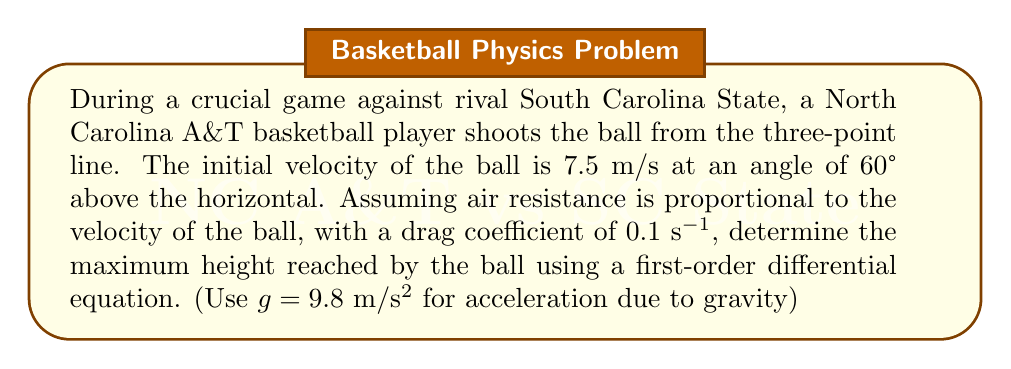Give your solution to this math problem. To solve this problem, we'll use a first-order differential equation to model the vertical motion of the basketball.

1) Let's define our variables:
   $y$ = vertical position of the ball
   $v$ = vertical velocity of the ball
   $t$ = time
   $k$ = drag coefficient (0.1 s^(-1))
   $g$ = acceleration due to gravity (9.8 m/s^2)

2) The initial vertical velocity $v_0$ is:
   $v_0 = 7.5 \sin(60°) = 7.5 * 0.866 = 6.495$ m/s

3) The differential equation for the vertical velocity is:
   $$\frac{dv}{dt} = -g - kv$$

4) This is a first-order linear differential equation. The solution is:
   $$v(t) = \frac{g}{k}(e^{-kt} - 1) + v_0e^{-kt}$$

5) To find the maximum height, we need to find when $v(t) = 0$:
   $$0 = \frac{g}{k}(e^{-kt} - 1) + v_0e^{-kt}$$

6) Solving for $t$:
   $$e^{-kt} = \frac{g}{g+kv_0}$$
   $$t = -\frac{1}{k}\ln(\frac{g}{g+kv_0})$$

7) Substituting the values:
   $$t = -\frac{1}{0.1}\ln(\frac{9.8}{9.8+0.1*6.495}) = 0.629 \text{ seconds}$$

8) Now we can find the maximum height by integrating the velocity equation:
   $$y(t) = \int_0^t v(t) dt = -\frac{g}{k^2}(e^{-kt} - 1) - \frac{g}{k}t - \frac{v_0}{k}(e^{-kt} - 1)$$

9) Substituting $t = 0.629$ into this equation:
   $$y(0.629) = -\frac{9.8}{0.1^2}(e^{-0.1*0.629} - 1) - \frac{9.8}{0.1}*0.629 - \frac{6.495}{0.1}(e^{-0.1*0.629} - 1)$$

10) Calculating this value gives us the maximum height.
Answer: The maximum height reached by the basketball is approximately 2.15 meters. 